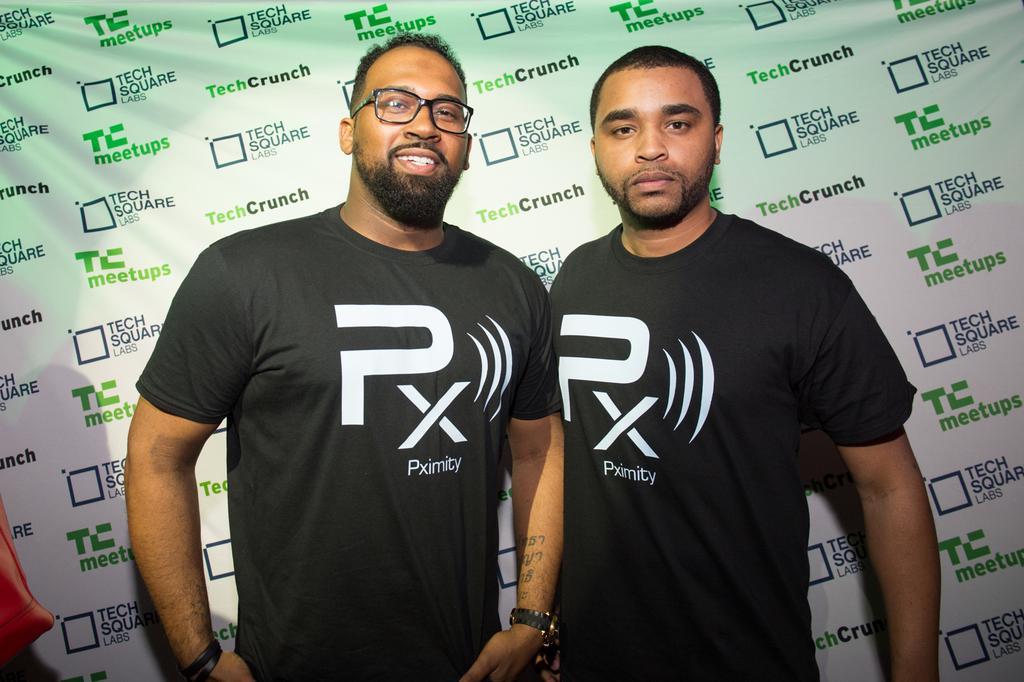Describe this image in one or two sentences. In this image two persons are standing. Left side person is wearing spectacles. Behind them there is a banner. Left bottom there is an object. 